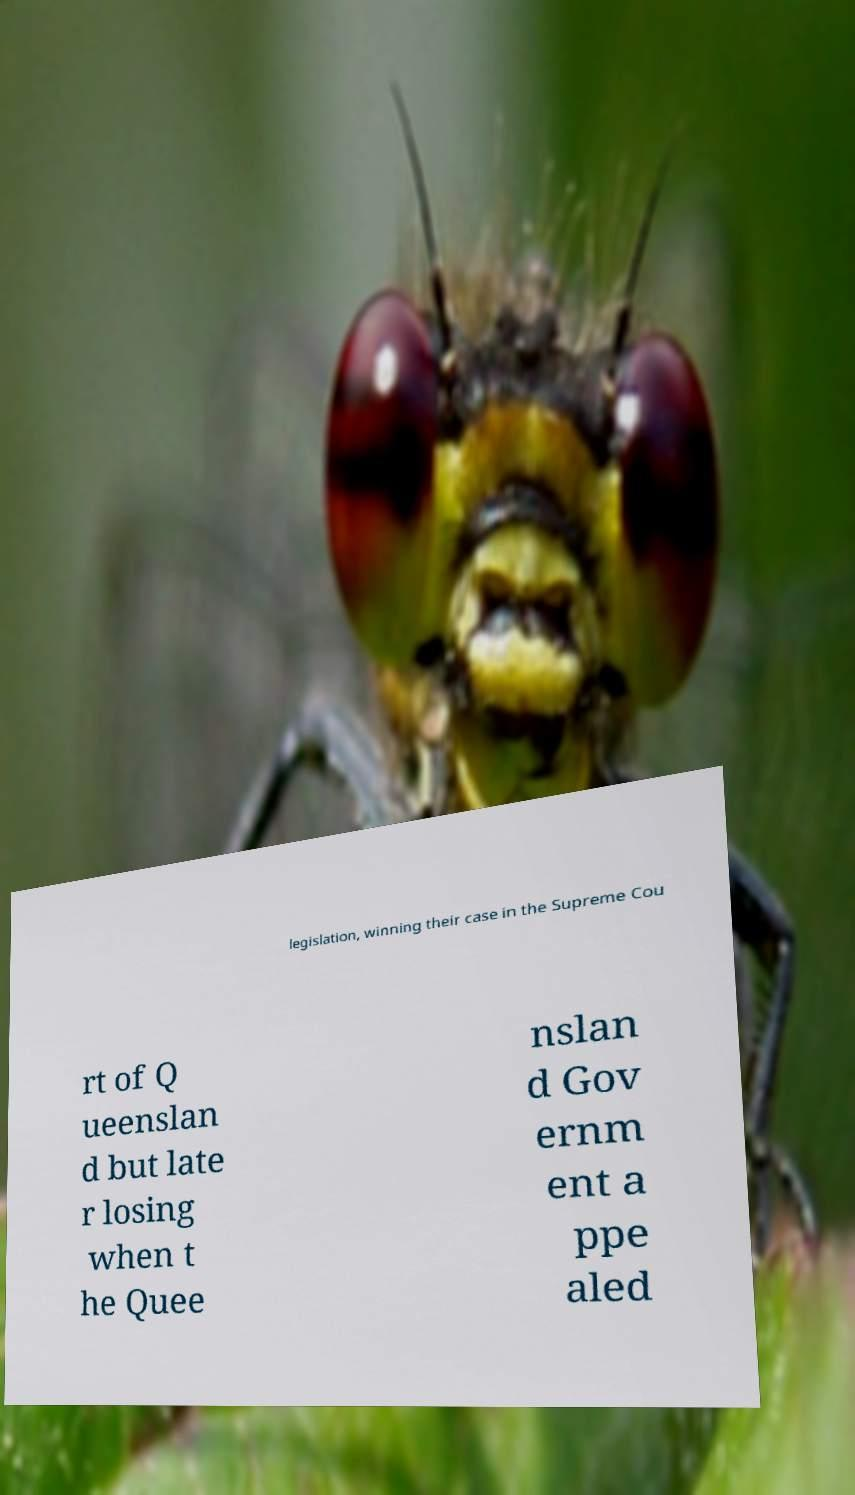For documentation purposes, I need the text within this image transcribed. Could you provide that? legislation, winning their case in the Supreme Cou rt of Q ueenslan d but late r losing when t he Quee nslan d Gov ernm ent a ppe aled 